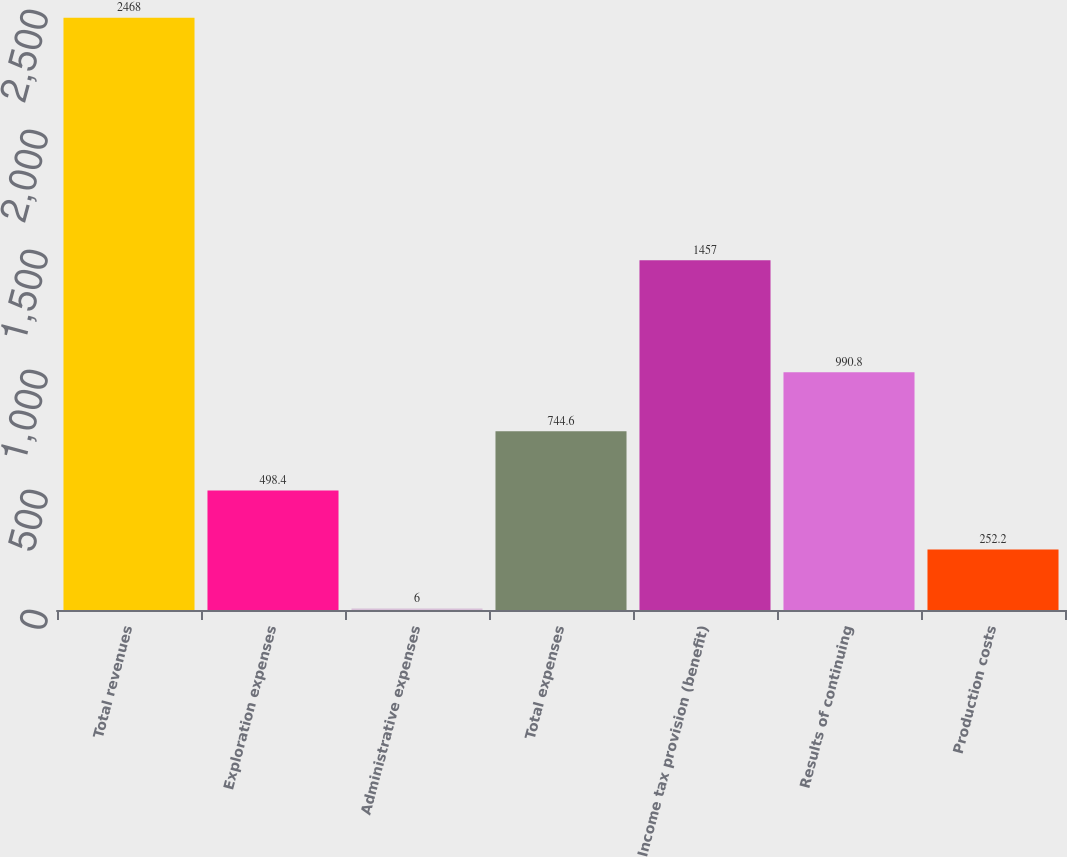Convert chart. <chart><loc_0><loc_0><loc_500><loc_500><bar_chart><fcel>Total revenues<fcel>Exploration expenses<fcel>Administrative expenses<fcel>Total expenses<fcel>Income tax provision (benefit)<fcel>Results of continuing<fcel>Production costs<nl><fcel>2468<fcel>498.4<fcel>6<fcel>744.6<fcel>1457<fcel>990.8<fcel>252.2<nl></chart> 